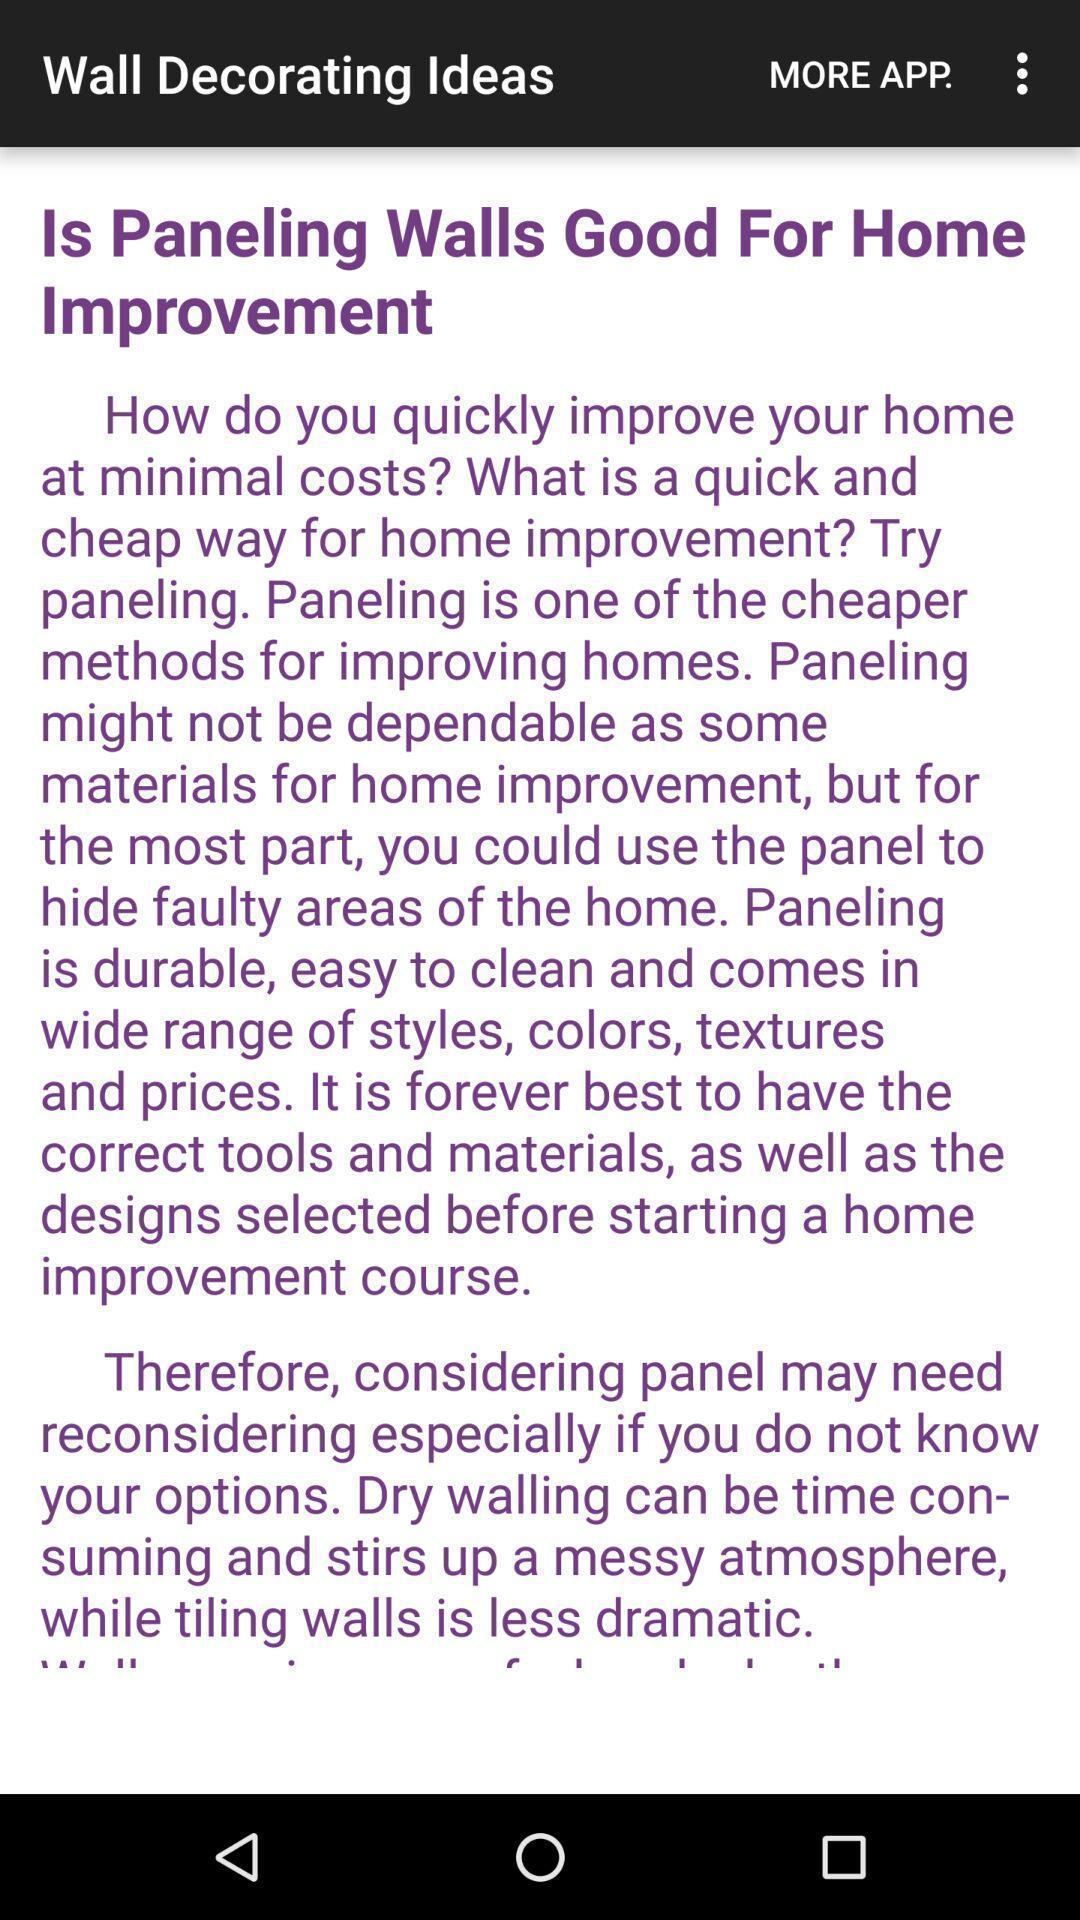Tell me what you see in this picture. Page showing information about wall decoration ideas. 